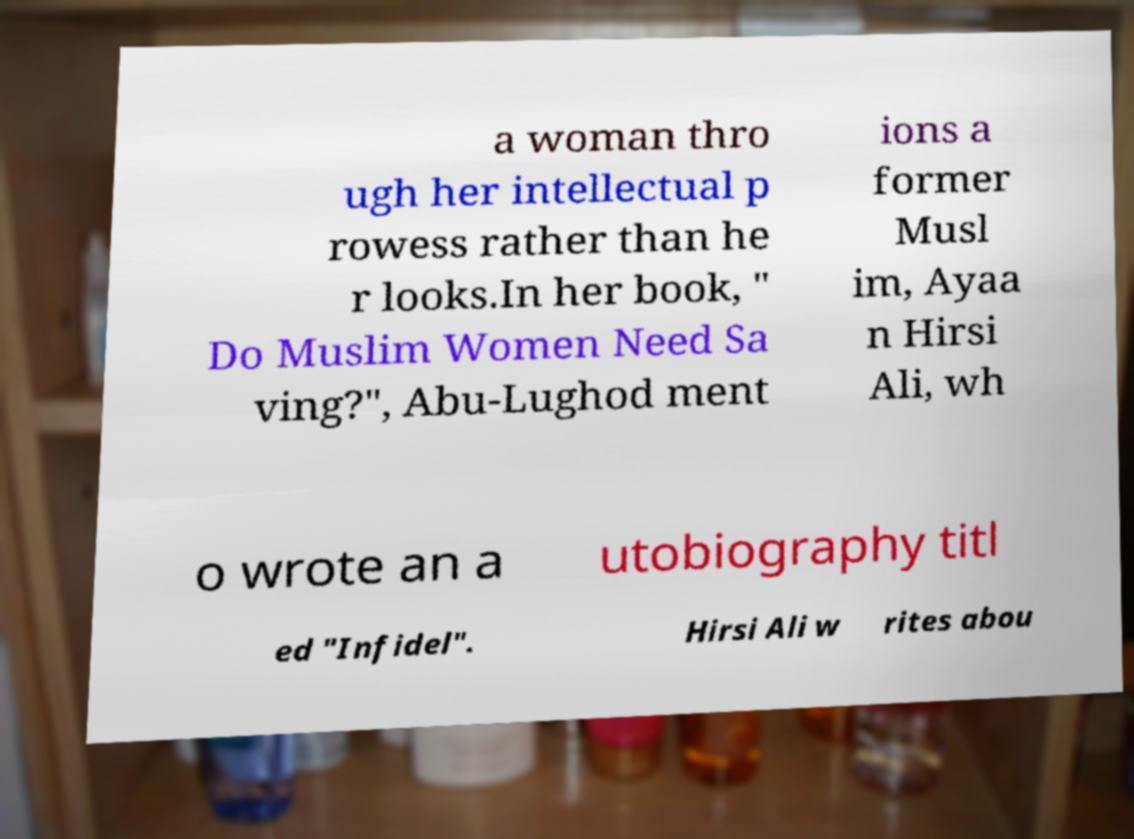Could you assist in decoding the text presented in this image and type it out clearly? a woman thro ugh her intellectual p rowess rather than he r looks.In her book, " Do Muslim Women Need Sa ving?", Abu-Lughod ment ions a former Musl im, Ayaa n Hirsi Ali, wh o wrote an a utobiography titl ed "Infidel". Hirsi Ali w rites abou 